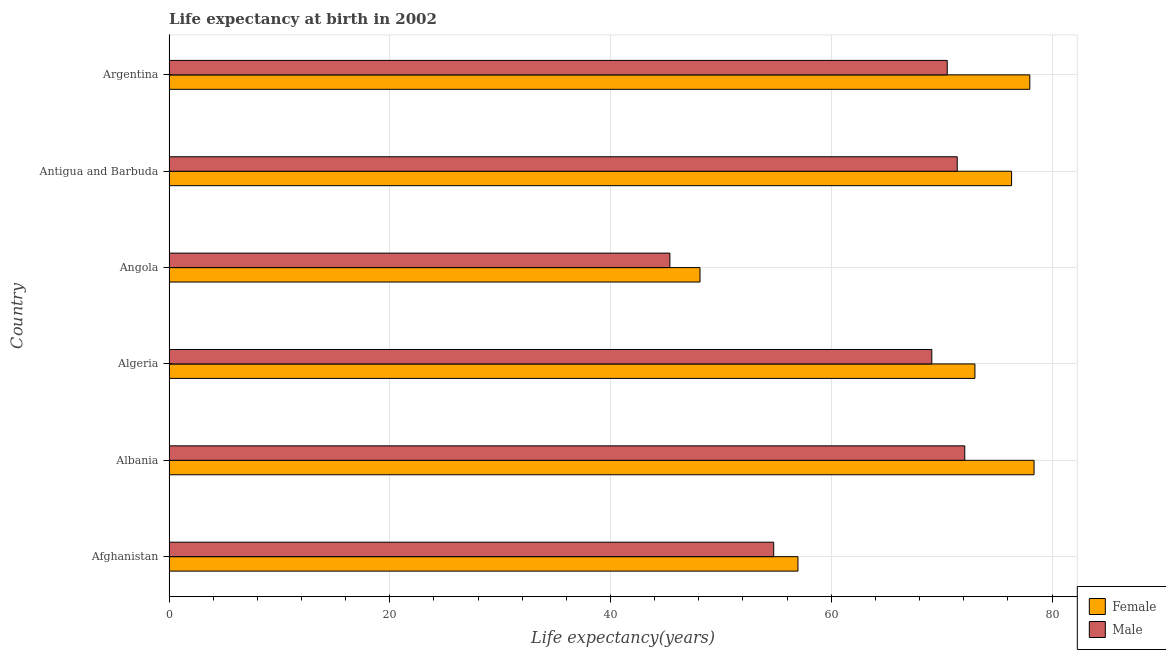Are the number of bars per tick equal to the number of legend labels?
Your answer should be very brief. Yes. How many bars are there on the 5th tick from the top?
Offer a very short reply. 2. What is the life expectancy(male) in Antigua and Barbuda?
Keep it short and to the point. 71.41. Across all countries, what is the maximum life expectancy(male)?
Provide a short and direct response. 72.1. Across all countries, what is the minimum life expectancy(female)?
Make the answer very short. 48.11. In which country was the life expectancy(female) maximum?
Your answer should be very brief. Albania. In which country was the life expectancy(female) minimum?
Offer a very short reply. Angola. What is the total life expectancy(male) in the graph?
Your response must be concise. 383.29. What is the difference between the life expectancy(female) in Afghanistan and that in Antigua and Barbuda?
Provide a succinct answer. -19.36. What is the difference between the life expectancy(female) in Antigua and Barbuda and the life expectancy(male) in Afghanistan?
Ensure brevity in your answer.  21.55. What is the average life expectancy(female) per country?
Keep it short and to the point. 68.47. What is the difference between the life expectancy(male) and life expectancy(female) in Albania?
Keep it short and to the point. -6.28. What is the ratio of the life expectancy(female) in Albania to that in Algeria?
Offer a terse response. 1.07. What is the difference between the highest and the second highest life expectancy(female)?
Provide a succinct answer. 0.39. What is the difference between the highest and the lowest life expectancy(male)?
Provide a succinct answer. 26.72. In how many countries, is the life expectancy(male) greater than the average life expectancy(male) taken over all countries?
Offer a terse response. 4. Is the sum of the life expectancy(male) in Antigua and Barbuda and Argentina greater than the maximum life expectancy(female) across all countries?
Provide a short and direct response. Yes. What does the 2nd bar from the bottom in Argentina represents?
Give a very brief answer. Male. How many countries are there in the graph?
Give a very brief answer. 6. What is the difference between two consecutive major ticks on the X-axis?
Your response must be concise. 20. Does the graph contain any zero values?
Your response must be concise. No. Does the graph contain grids?
Ensure brevity in your answer.  Yes. Where does the legend appear in the graph?
Provide a succinct answer. Bottom right. What is the title of the graph?
Keep it short and to the point. Life expectancy at birth in 2002. Does "RDB nonconcessional" appear as one of the legend labels in the graph?
Keep it short and to the point. No. What is the label or title of the X-axis?
Ensure brevity in your answer.  Life expectancy(years). What is the label or title of the Y-axis?
Provide a succinct answer. Country. What is the Life expectancy(years) in Female in Afghanistan?
Provide a short and direct response. 56.98. What is the Life expectancy(years) of Male in Afghanistan?
Offer a very short reply. 54.78. What is the Life expectancy(years) of Female in Albania?
Ensure brevity in your answer.  78.37. What is the Life expectancy(years) of Male in Albania?
Ensure brevity in your answer.  72.1. What is the Life expectancy(years) in Female in Algeria?
Ensure brevity in your answer.  73.02. What is the Life expectancy(years) of Male in Algeria?
Provide a succinct answer. 69.11. What is the Life expectancy(years) of Female in Angola?
Provide a succinct answer. 48.11. What is the Life expectancy(years) of Male in Angola?
Your response must be concise. 45.38. What is the Life expectancy(years) in Female in Antigua and Barbuda?
Offer a terse response. 76.34. What is the Life expectancy(years) of Male in Antigua and Barbuda?
Provide a succinct answer. 71.41. What is the Life expectancy(years) in Female in Argentina?
Provide a short and direct response. 77.99. What is the Life expectancy(years) in Male in Argentina?
Keep it short and to the point. 70.51. Across all countries, what is the maximum Life expectancy(years) of Female?
Provide a succinct answer. 78.37. Across all countries, what is the maximum Life expectancy(years) of Male?
Your answer should be compact. 72.1. Across all countries, what is the minimum Life expectancy(years) of Female?
Make the answer very short. 48.11. Across all countries, what is the minimum Life expectancy(years) in Male?
Offer a terse response. 45.38. What is the total Life expectancy(years) of Female in the graph?
Ensure brevity in your answer.  410.81. What is the total Life expectancy(years) of Male in the graph?
Make the answer very short. 383.29. What is the difference between the Life expectancy(years) of Female in Afghanistan and that in Albania?
Offer a very short reply. -21.39. What is the difference between the Life expectancy(years) in Male in Afghanistan and that in Albania?
Provide a short and direct response. -17.31. What is the difference between the Life expectancy(years) of Female in Afghanistan and that in Algeria?
Your answer should be very brief. -16.03. What is the difference between the Life expectancy(years) of Male in Afghanistan and that in Algeria?
Your response must be concise. -14.32. What is the difference between the Life expectancy(years) in Female in Afghanistan and that in Angola?
Offer a very short reply. 8.87. What is the difference between the Life expectancy(years) of Male in Afghanistan and that in Angola?
Give a very brief answer. 9.4. What is the difference between the Life expectancy(years) of Female in Afghanistan and that in Antigua and Barbuda?
Offer a very short reply. -19.36. What is the difference between the Life expectancy(years) of Male in Afghanistan and that in Antigua and Barbuda?
Provide a short and direct response. -16.63. What is the difference between the Life expectancy(years) of Female in Afghanistan and that in Argentina?
Make the answer very short. -21. What is the difference between the Life expectancy(years) in Male in Afghanistan and that in Argentina?
Offer a terse response. -15.72. What is the difference between the Life expectancy(years) of Female in Albania and that in Algeria?
Keep it short and to the point. 5.36. What is the difference between the Life expectancy(years) of Male in Albania and that in Algeria?
Your answer should be compact. 2.99. What is the difference between the Life expectancy(years) in Female in Albania and that in Angola?
Your answer should be very brief. 30.26. What is the difference between the Life expectancy(years) of Male in Albania and that in Angola?
Your answer should be very brief. 26.71. What is the difference between the Life expectancy(years) in Female in Albania and that in Antigua and Barbuda?
Give a very brief answer. 2.04. What is the difference between the Life expectancy(years) of Male in Albania and that in Antigua and Barbuda?
Offer a terse response. 0.68. What is the difference between the Life expectancy(years) of Female in Albania and that in Argentina?
Offer a terse response. 0.39. What is the difference between the Life expectancy(years) in Male in Albania and that in Argentina?
Make the answer very short. 1.59. What is the difference between the Life expectancy(years) in Female in Algeria and that in Angola?
Keep it short and to the point. 24.91. What is the difference between the Life expectancy(years) of Male in Algeria and that in Angola?
Give a very brief answer. 23.73. What is the difference between the Life expectancy(years) in Female in Algeria and that in Antigua and Barbuda?
Offer a terse response. -3.32. What is the difference between the Life expectancy(years) in Male in Algeria and that in Antigua and Barbuda?
Offer a very short reply. -2.3. What is the difference between the Life expectancy(years) of Female in Algeria and that in Argentina?
Offer a very short reply. -4.97. What is the difference between the Life expectancy(years) of Male in Algeria and that in Argentina?
Provide a succinct answer. -1.4. What is the difference between the Life expectancy(years) in Female in Angola and that in Antigua and Barbuda?
Your answer should be compact. -28.23. What is the difference between the Life expectancy(years) of Male in Angola and that in Antigua and Barbuda?
Offer a terse response. -26.03. What is the difference between the Life expectancy(years) in Female in Angola and that in Argentina?
Make the answer very short. -29.88. What is the difference between the Life expectancy(years) of Male in Angola and that in Argentina?
Your answer should be compact. -25.13. What is the difference between the Life expectancy(years) of Female in Antigua and Barbuda and that in Argentina?
Provide a succinct answer. -1.65. What is the difference between the Life expectancy(years) of Male in Antigua and Barbuda and that in Argentina?
Offer a very short reply. 0.91. What is the difference between the Life expectancy(years) of Female in Afghanistan and the Life expectancy(years) of Male in Albania?
Make the answer very short. -15.11. What is the difference between the Life expectancy(years) of Female in Afghanistan and the Life expectancy(years) of Male in Algeria?
Offer a terse response. -12.13. What is the difference between the Life expectancy(years) in Female in Afghanistan and the Life expectancy(years) in Male in Angola?
Provide a short and direct response. 11.6. What is the difference between the Life expectancy(years) of Female in Afghanistan and the Life expectancy(years) of Male in Antigua and Barbuda?
Offer a terse response. -14.43. What is the difference between the Life expectancy(years) of Female in Afghanistan and the Life expectancy(years) of Male in Argentina?
Make the answer very short. -13.52. What is the difference between the Life expectancy(years) in Female in Albania and the Life expectancy(years) in Male in Algeria?
Ensure brevity in your answer.  9.26. What is the difference between the Life expectancy(years) in Female in Albania and the Life expectancy(years) in Male in Angola?
Keep it short and to the point. 32.99. What is the difference between the Life expectancy(years) of Female in Albania and the Life expectancy(years) of Male in Antigua and Barbuda?
Offer a very short reply. 6.96. What is the difference between the Life expectancy(years) in Female in Albania and the Life expectancy(years) in Male in Argentina?
Your response must be concise. 7.87. What is the difference between the Life expectancy(years) of Female in Algeria and the Life expectancy(years) of Male in Angola?
Keep it short and to the point. 27.64. What is the difference between the Life expectancy(years) in Female in Algeria and the Life expectancy(years) in Male in Antigua and Barbuda?
Offer a very short reply. 1.6. What is the difference between the Life expectancy(years) in Female in Algeria and the Life expectancy(years) in Male in Argentina?
Make the answer very short. 2.51. What is the difference between the Life expectancy(years) in Female in Angola and the Life expectancy(years) in Male in Antigua and Barbuda?
Give a very brief answer. -23.3. What is the difference between the Life expectancy(years) in Female in Angola and the Life expectancy(years) in Male in Argentina?
Ensure brevity in your answer.  -22.4. What is the difference between the Life expectancy(years) of Female in Antigua and Barbuda and the Life expectancy(years) of Male in Argentina?
Ensure brevity in your answer.  5.83. What is the average Life expectancy(years) in Female per country?
Provide a succinct answer. 68.47. What is the average Life expectancy(years) in Male per country?
Your response must be concise. 63.88. What is the difference between the Life expectancy(years) in Female and Life expectancy(years) in Male in Afghanistan?
Provide a short and direct response. 2.2. What is the difference between the Life expectancy(years) in Female and Life expectancy(years) in Male in Albania?
Your response must be concise. 6.28. What is the difference between the Life expectancy(years) of Female and Life expectancy(years) of Male in Algeria?
Make the answer very short. 3.91. What is the difference between the Life expectancy(years) of Female and Life expectancy(years) of Male in Angola?
Make the answer very short. 2.73. What is the difference between the Life expectancy(years) in Female and Life expectancy(years) in Male in Antigua and Barbuda?
Your answer should be compact. 4.92. What is the difference between the Life expectancy(years) of Female and Life expectancy(years) of Male in Argentina?
Your answer should be compact. 7.48. What is the ratio of the Life expectancy(years) of Female in Afghanistan to that in Albania?
Make the answer very short. 0.73. What is the ratio of the Life expectancy(years) in Male in Afghanistan to that in Albania?
Your response must be concise. 0.76. What is the ratio of the Life expectancy(years) of Female in Afghanistan to that in Algeria?
Your answer should be very brief. 0.78. What is the ratio of the Life expectancy(years) in Male in Afghanistan to that in Algeria?
Give a very brief answer. 0.79. What is the ratio of the Life expectancy(years) in Female in Afghanistan to that in Angola?
Your answer should be very brief. 1.18. What is the ratio of the Life expectancy(years) in Male in Afghanistan to that in Angola?
Provide a succinct answer. 1.21. What is the ratio of the Life expectancy(years) of Female in Afghanistan to that in Antigua and Barbuda?
Keep it short and to the point. 0.75. What is the ratio of the Life expectancy(years) of Male in Afghanistan to that in Antigua and Barbuda?
Ensure brevity in your answer.  0.77. What is the ratio of the Life expectancy(years) of Female in Afghanistan to that in Argentina?
Offer a terse response. 0.73. What is the ratio of the Life expectancy(years) of Male in Afghanistan to that in Argentina?
Ensure brevity in your answer.  0.78. What is the ratio of the Life expectancy(years) of Female in Albania to that in Algeria?
Make the answer very short. 1.07. What is the ratio of the Life expectancy(years) of Male in Albania to that in Algeria?
Keep it short and to the point. 1.04. What is the ratio of the Life expectancy(years) in Female in Albania to that in Angola?
Your answer should be very brief. 1.63. What is the ratio of the Life expectancy(years) of Male in Albania to that in Angola?
Ensure brevity in your answer.  1.59. What is the ratio of the Life expectancy(years) of Female in Albania to that in Antigua and Barbuda?
Your answer should be very brief. 1.03. What is the ratio of the Life expectancy(years) in Male in Albania to that in Antigua and Barbuda?
Your response must be concise. 1.01. What is the ratio of the Life expectancy(years) in Male in Albania to that in Argentina?
Keep it short and to the point. 1.02. What is the ratio of the Life expectancy(years) in Female in Algeria to that in Angola?
Ensure brevity in your answer.  1.52. What is the ratio of the Life expectancy(years) of Male in Algeria to that in Angola?
Your response must be concise. 1.52. What is the ratio of the Life expectancy(years) of Female in Algeria to that in Antigua and Barbuda?
Ensure brevity in your answer.  0.96. What is the ratio of the Life expectancy(years) of Male in Algeria to that in Antigua and Barbuda?
Ensure brevity in your answer.  0.97. What is the ratio of the Life expectancy(years) in Female in Algeria to that in Argentina?
Keep it short and to the point. 0.94. What is the ratio of the Life expectancy(years) of Male in Algeria to that in Argentina?
Offer a very short reply. 0.98. What is the ratio of the Life expectancy(years) in Female in Angola to that in Antigua and Barbuda?
Provide a short and direct response. 0.63. What is the ratio of the Life expectancy(years) in Male in Angola to that in Antigua and Barbuda?
Your answer should be very brief. 0.64. What is the ratio of the Life expectancy(years) in Female in Angola to that in Argentina?
Give a very brief answer. 0.62. What is the ratio of the Life expectancy(years) of Male in Angola to that in Argentina?
Offer a terse response. 0.64. What is the ratio of the Life expectancy(years) of Female in Antigua and Barbuda to that in Argentina?
Your answer should be very brief. 0.98. What is the ratio of the Life expectancy(years) in Male in Antigua and Barbuda to that in Argentina?
Offer a terse response. 1.01. What is the difference between the highest and the second highest Life expectancy(years) of Female?
Make the answer very short. 0.39. What is the difference between the highest and the second highest Life expectancy(years) of Male?
Provide a short and direct response. 0.68. What is the difference between the highest and the lowest Life expectancy(years) in Female?
Provide a succinct answer. 30.26. What is the difference between the highest and the lowest Life expectancy(years) of Male?
Make the answer very short. 26.71. 